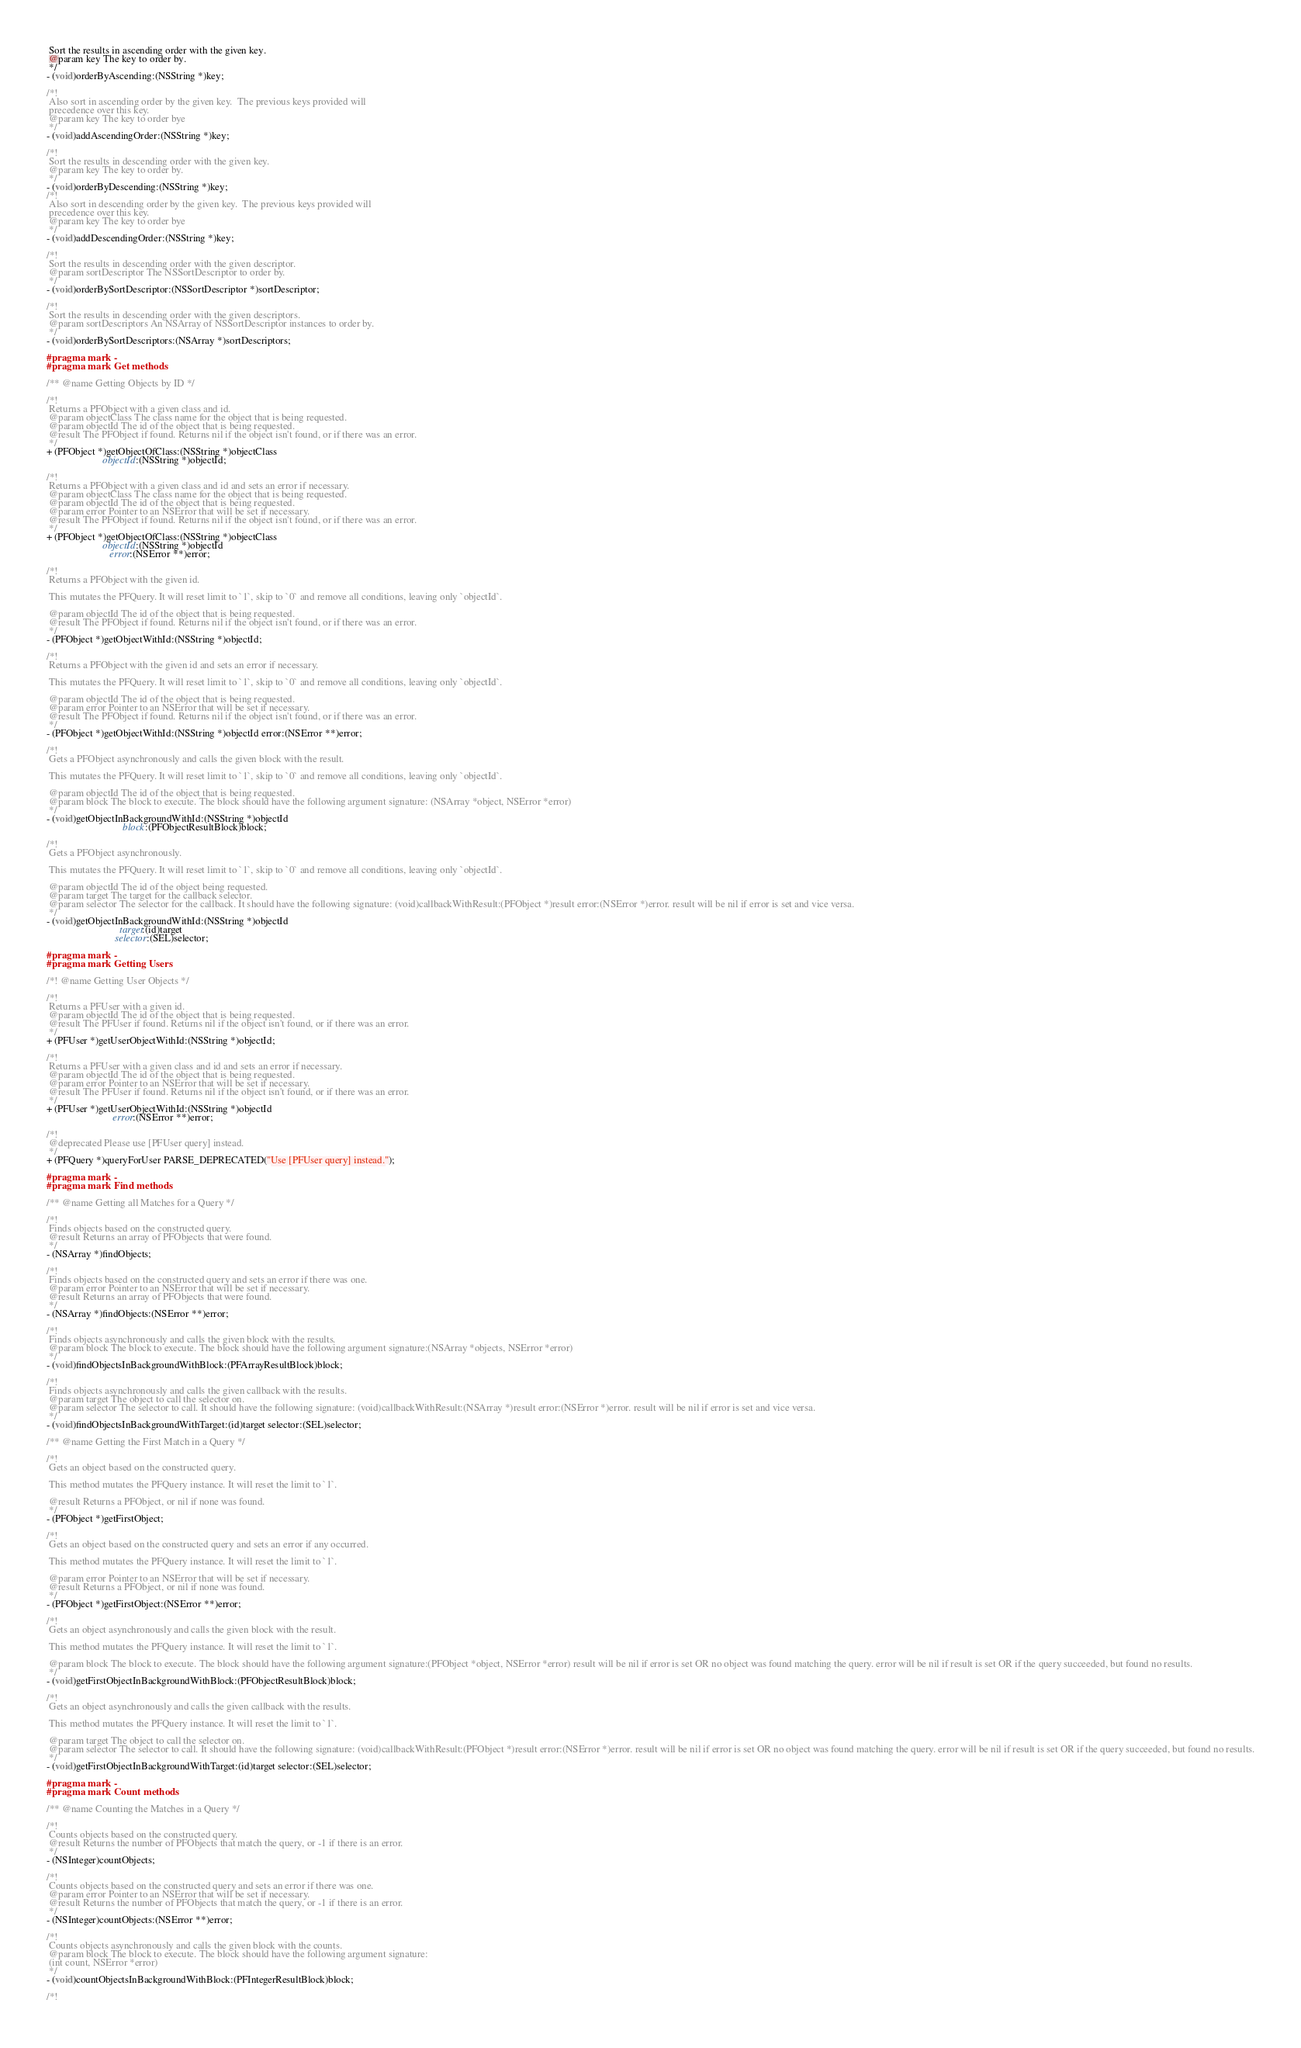Convert code to text. <code><loc_0><loc_0><loc_500><loc_500><_C_> Sort the results in ascending order with the given key.
 @param key The key to order by.
 */
- (void)orderByAscending:(NSString *)key;

/*!
 Also sort in ascending order by the given key.  The previous keys provided will
 precedence over this key.
 @param key The key to order bye
 */
- (void)addAscendingOrder:(NSString *)key;

/*!
 Sort the results in descending order with the given key.
 @param key The key to order by.
 */
- (void)orderByDescending:(NSString *)key;
/*!
 Also sort in descending order by the given key.  The previous keys provided will
 precedence over this key.
 @param key The key to order bye
 */
- (void)addDescendingOrder:(NSString *)key;

/*!
 Sort the results in descending order with the given descriptor.
 @param sortDescriptor The NSSortDescriptor to order by.
 */
- (void)orderBySortDescriptor:(NSSortDescriptor *)sortDescriptor;

/*!
 Sort the results in descending order with the given descriptors.
 @param sortDescriptors An NSArray of NSSortDescriptor instances to order by.
 */
- (void)orderBySortDescriptors:(NSArray *)sortDescriptors;

#pragma mark -
#pragma mark Get methods

/** @name Getting Objects by ID */

/*!
 Returns a PFObject with a given class and id.
 @param objectClass The class name for the object that is being requested.
 @param objectId The id of the object that is being requested.
 @result The PFObject if found. Returns nil if the object isn't found, or if there was an error.
 */
+ (PFObject *)getObjectOfClass:(NSString *)objectClass
                      objectId:(NSString *)objectId;

/*!
 Returns a PFObject with a given class and id and sets an error if necessary.
 @param objectClass The class name for the object that is being requested.
 @param objectId The id of the object that is being requested.
 @param error Pointer to an NSError that will be set if necessary.
 @result The PFObject if found. Returns nil if the object isn't found, or if there was an error.
 */
+ (PFObject *)getObjectOfClass:(NSString *)objectClass
                      objectId:(NSString *)objectId
                         error:(NSError **)error;

/*!
 Returns a PFObject with the given id.

 This mutates the PFQuery. It will reset limit to `1`, skip to `0` and remove all conditions, leaving only `objectId`.

 @param objectId The id of the object that is being requested.
 @result The PFObject if found. Returns nil if the object isn't found, or if there was an error.
 */
- (PFObject *)getObjectWithId:(NSString *)objectId;

/*!
 Returns a PFObject with the given id and sets an error if necessary.

 This mutates the PFQuery. It will reset limit to `1`, skip to `0` and remove all conditions, leaving only `objectId`.

 @param objectId The id of the object that is being requested.
 @param error Pointer to an NSError that will be set if necessary.
 @result The PFObject if found. Returns nil if the object isn't found, or if there was an error.
 */
- (PFObject *)getObjectWithId:(NSString *)objectId error:(NSError **)error;

/*!
 Gets a PFObject asynchronously and calls the given block with the result.

 This mutates the PFQuery. It will reset limit to `1`, skip to `0` and remove all conditions, leaving only `objectId`.

 @param objectId The id of the object that is being requested.
 @param block The block to execute. The block should have the following argument signature: (NSArray *object, NSError *error)
 */
- (void)getObjectInBackgroundWithId:(NSString *)objectId
                              block:(PFObjectResultBlock)block;

/*!
 Gets a PFObject asynchronously.

 This mutates the PFQuery. It will reset limit to `1`, skip to `0` and remove all conditions, leaving only `objectId`.

 @param objectId The id of the object being requested.
 @param target The target for the callback selector.
 @param selector The selector for the callback. It should have the following signature: (void)callbackWithResult:(PFObject *)result error:(NSError *)error. result will be nil if error is set and vice versa.
 */
- (void)getObjectInBackgroundWithId:(NSString *)objectId
                             target:(id)target
                           selector:(SEL)selector;

#pragma mark -
#pragma mark Getting Users

/*! @name Getting User Objects */

/*!
 Returns a PFUser with a given id.
 @param objectId The id of the object that is being requested.
 @result The PFUser if found. Returns nil if the object isn't found, or if there was an error.
 */
+ (PFUser *)getUserObjectWithId:(NSString *)objectId;

/*!
 Returns a PFUser with a given class and id and sets an error if necessary.
 @param objectId The id of the object that is being requested.
 @param error Pointer to an NSError that will be set if necessary.
 @result The PFUser if found. Returns nil if the object isn't found, or if there was an error.
 */
+ (PFUser *)getUserObjectWithId:(NSString *)objectId
                          error:(NSError **)error;

/*!
 @deprecated Please use [PFUser query] instead.
 */
+ (PFQuery *)queryForUser PARSE_DEPRECATED("Use [PFUser query] instead.");

#pragma mark -
#pragma mark Find methods

/** @name Getting all Matches for a Query */

/*!
 Finds objects based on the constructed query.
 @result Returns an array of PFObjects that were found.
 */
- (NSArray *)findObjects;

/*!
 Finds objects based on the constructed query and sets an error if there was one.
 @param error Pointer to an NSError that will be set if necessary.
 @result Returns an array of PFObjects that were found.
 */
- (NSArray *)findObjects:(NSError **)error;

/*!
 Finds objects asynchronously and calls the given block with the results.
 @param block The block to execute. The block should have the following argument signature:(NSArray *objects, NSError *error)
 */
- (void)findObjectsInBackgroundWithBlock:(PFArrayResultBlock)block;

/*!
 Finds objects asynchronously and calls the given callback with the results.
 @param target The object to call the selector on.
 @param selector The selector to call. It should have the following signature: (void)callbackWithResult:(NSArray *)result error:(NSError *)error. result will be nil if error is set and vice versa.
 */
- (void)findObjectsInBackgroundWithTarget:(id)target selector:(SEL)selector;

/** @name Getting the First Match in a Query */

/*!
 Gets an object based on the constructed query.

 This method mutates the PFQuery instance. It will reset the limit to `1`.

 @result Returns a PFObject, or nil if none was found.
 */
- (PFObject *)getFirstObject;

/*!
 Gets an object based on the constructed query and sets an error if any occurred.

 This method mutates the PFQuery instance. It will reset the limit to `1`.

 @param error Pointer to an NSError that will be set if necessary.
 @result Returns a PFObject, or nil if none was found.
 */
- (PFObject *)getFirstObject:(NSError **)error;

/*!
 Gets an object asynchronously and calls the given block with the result.

 This method mutates the PFQuery instance. It will reset the limit to `1`.

 @param block The block to execute. The block should have the following argument signature:(PFObject *object, NSError *error) result will be nil if error is set OR no object was found matching the query. error will be nil if result is set OR if the query succeeded, but found no results.
 */
- (void)getFirstObjectInBackgroundWithBlock:(PFObjectResultBlock)block;

/*!
 Gets an object asynchronously and calls the given callback with the results.

 This method mutates the PFQuery instance. It will reset the limit to `1`.

 @param target The object to call the selector on.
 @param selector The selector to call. It should have the following signature: (void)callbackWithResult:(PFObject *)result error:(NSError *)error. result will be nil if error is set OR no object was found matching the query. error will be nil if result is set OR if the query succeeded, but found no results.
 */
- (void)getFirstObjectInBackgroundWithTarget:(id)target selector:(SEL)selector;

#pragma mark -
#pragma mark Count methods

/** @name Counting the Matches in a Query */

/*!
 Counts objects based on the constructed query.
 @result Returns the number of PFObjects that match the query, or -1 if there is an error.
 */
- (NSInteger)countObjects;

/*!
 Counts objects based on the constructed query and sets an error if there was one.
 @param error Pointer to an NSError that will be set if necessary.
 @result Returns the number of PFObjects that match the query, or -1 if there is an error.
 */
- (NSInteger)countObjects:(NSError **)error;

/*!
 Counts objects asynchronously and calls the given block with the counts.
 @param block The block to execute. The block should have the following argument signature:
 (int count, NSError *error)
 */
- (void)countObjectsInBackgroundWithBlock:(PFIntegerResultBlock)block;

/*!</code> 